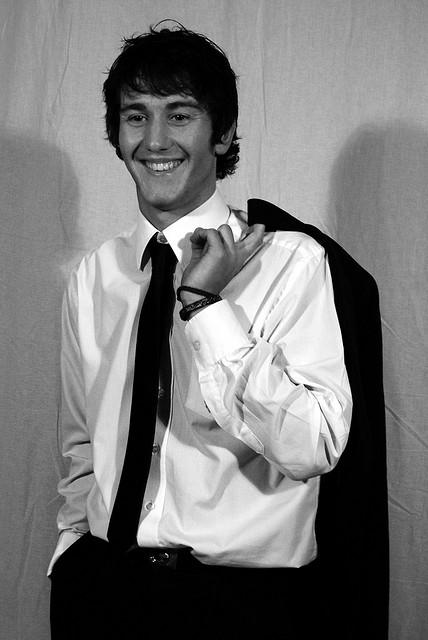What is hanging off of the boy's finger?
Short answer required. Jacket. Is this person wearing a tie?
Quick response, please. Yes. What catalog is this man posing for?
Quick response, please. Sears. 